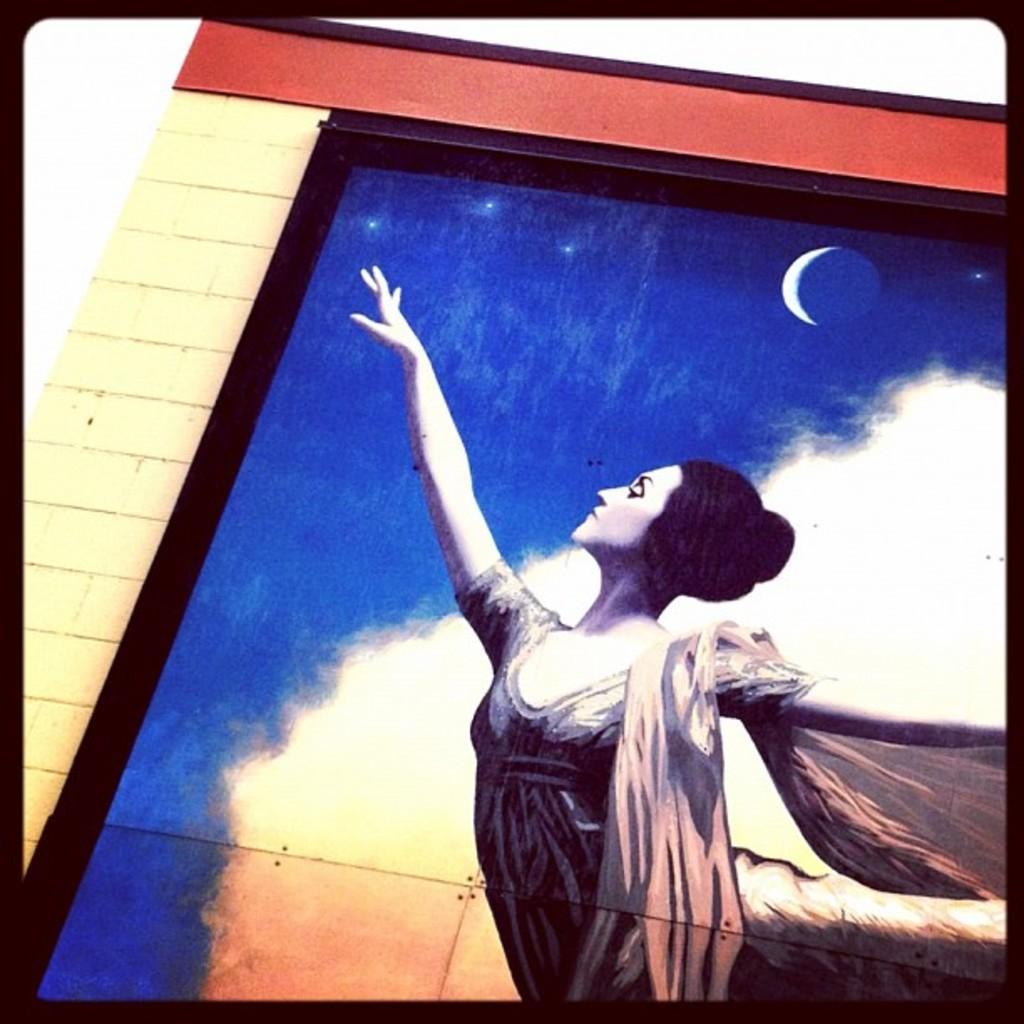Can you describe this image briefly? In this image, we can see a picture, in that picture there is a woman standing, at the top there is a white color half moon, we can see a brick wall. 